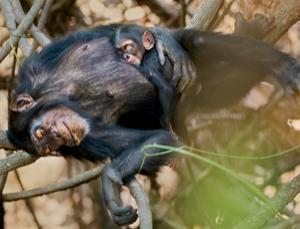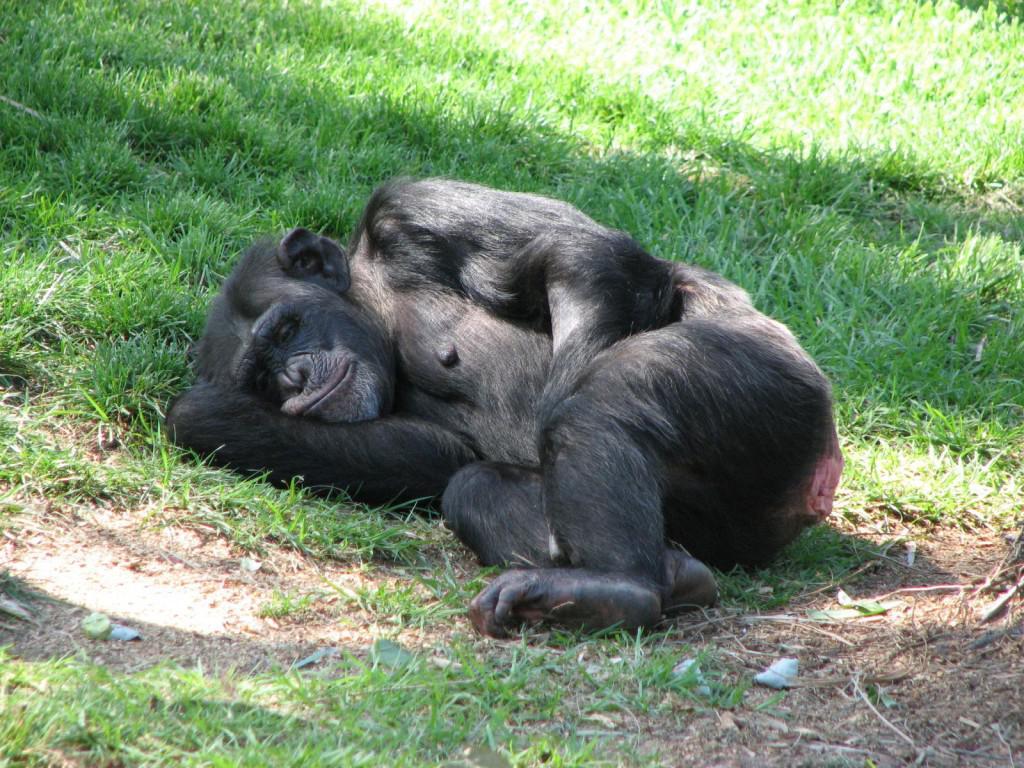The first image is the image on the left, the second image is the image on the right. Given the left and right images, does the statement "An image shows a baby chimp sleeping on top of an adult chimp." hold true? Answer yes or no. Yes. The first image is the image on the left, the second image is the image on the right. For the images shown, is this caption "One animal is sleeping on another in the image on the left." true? Answer yes or no. Yes. 